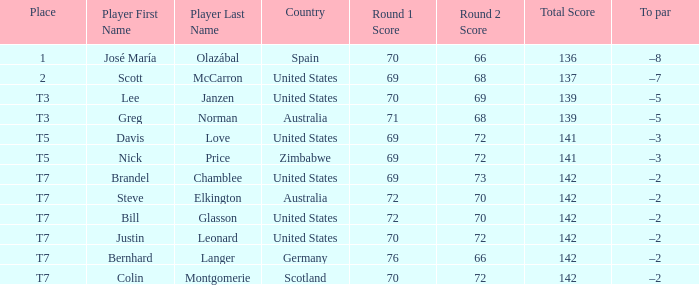WHich Score has a To par of –3, and a Country of united states? 69-72=141. 